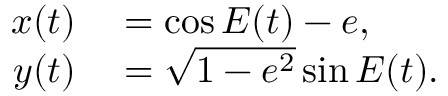<formula> <loc_0><loc_0><loc_500><loc_500>\begin{array} { r l } { x ( t ) } & = \cos { E ( t ) } - e , } \\ { y ( t ) } & = \sqrt { 1 - e ^ { 2 } } \sin { E ( t ) } . } \end{array}</formula> 